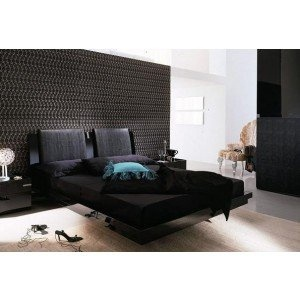Describe the objects in this image and their specific colors. I can see bed in white, black, gray, and blue tones and chair in white, darkgray, black, tan, and gray tones in this image. 